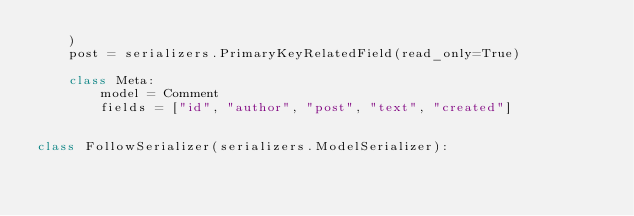<code> <loc_0><loc_0><loc_500><loc_500><_Python_>    )
    post = serializers.PrimaryKeyRelatedField(read_only=True)

    class Meta:
        model = Comment
        fields = ["id", "author", "post", "text", "created"]


class FollowSerializer(serializers.ModelSerializer):</code> 